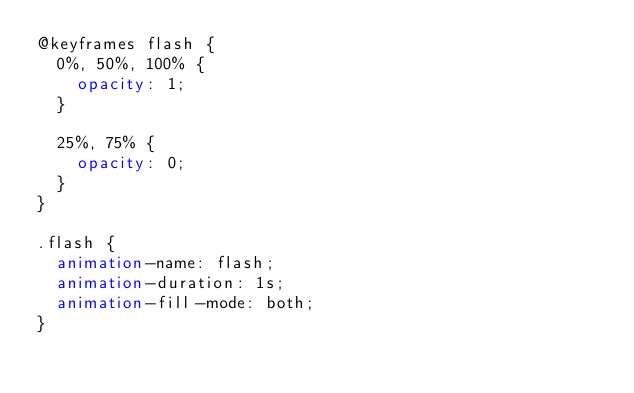Convert code to text. <code><loc_0><loc_0><loc_500><loc_500><_CSS_>@keyframes flash {
  0%, 50%, 100% {
    opacity: 1;
  }

  25%, 75% {
    opacity: 0;
  }
}

.flash {
  animation-name: flash;
  animation-duration: 1s;
  animation-fill-mode: both;
}
</code> 